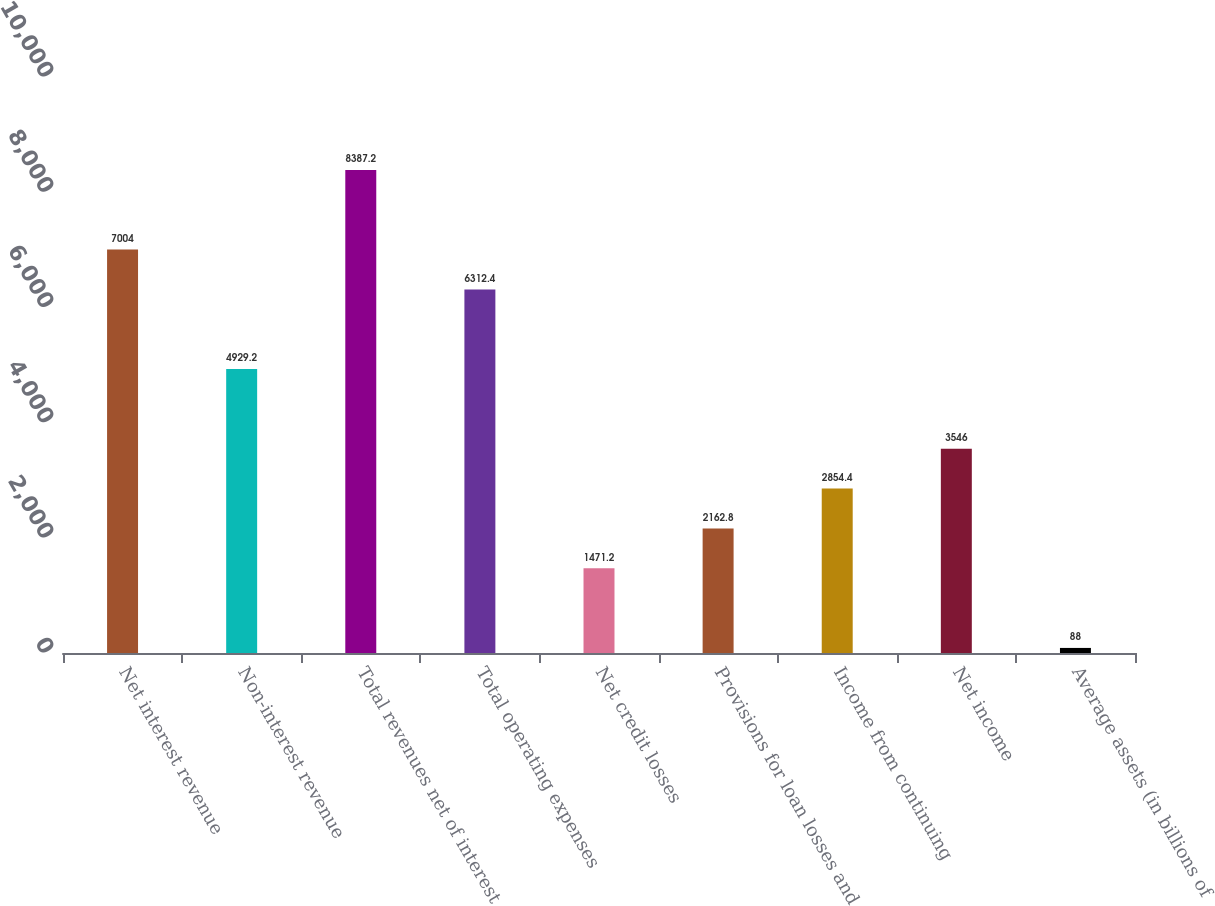Convert chart to OTSL. <chart><loc_0><loc_0><loc_500><loc_500><bar_chart><fcel>Net interest revenue<fcel>Non-interest revenue<fcel>Total revenues net of interest<fcel>Total operating expenses<fcel>Net credit losses<fcel>Provisions for loan losses and<fcel>Income from continuing<fcel>Net income<fcel>Average assets (in billions of<nl><fcel>7004<fcel>4929.2<fcel>8387.2<fcel>6312.4<fcel>1471.2<fcel>2162.8<fcel>2854.4<fcel>3546<fcel>88<nl></chart> 